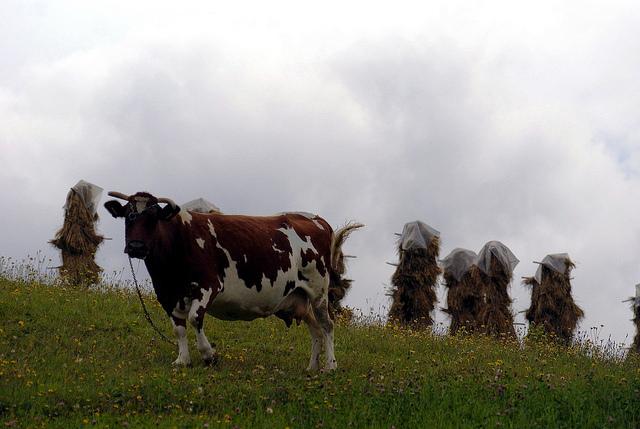Is the cow ready to be milked?
Short answer required. No. How many cows are here?
Be succinct. 1. What is the long furry thing at the back of the animal?
Answer briefly. Tail. Do this animals have long hair?
Short answer required. No. How's the weather?
Write a very short answer. Cloudy. How many animals are in this scene?
Be succinct. 1. What color is the cow in front?
Answer briefly. Brown and white. What gender is this animal?
Be succinct. Female. 